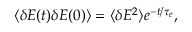<formula> <loc_0><loc_0><loc_500><loc_500>\langle \delta E ( t ) \delta E ( 0 ) \rangle = \langle \delta E ^ { 2 } \rangle e ^ { - t / \tau _ { e } } ,</formula> 